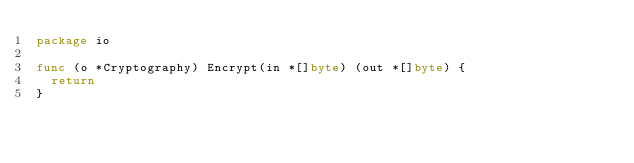Convert code to text. <code><loc_0><loc_0><loc_500><loc_500><_Go_>package io

func (o *Cryptography) Encrypt(in *[]byte) (out *[]byte) {
	return
}
</code> 